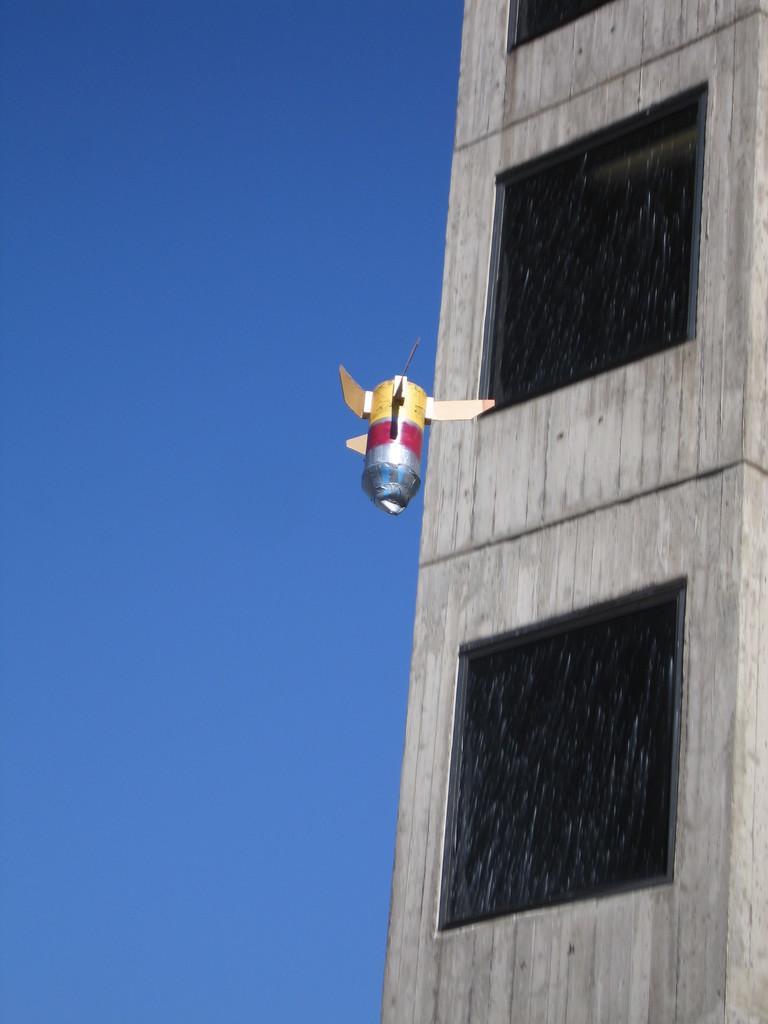In one or two sentences, can you explain what this image depicts? Here in this picture, in the middle we can see a thing flying in the air and beside that we can see a building with number of windows on it and we can also see the sky is clear. 